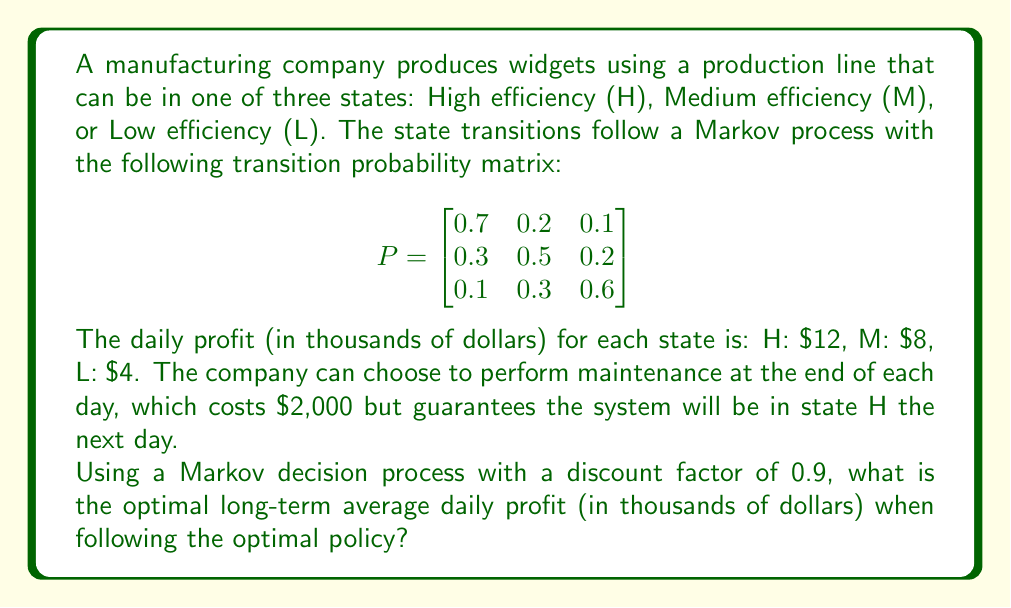Show me your answer to this math problem. To solve this Markov decision process, we'll use value iteration:

1) Define the value function $V(s)$ for each state s ∈ {H, M, L}.

2) Initialize $V_0(s) = 0$ for all states.

3) For each iteration k, update the value function:

   $V_{k+1}(s) = \max\{R(s) + \gamma \sum_{s'} P(s'|s)V_k(s'), R_m + \gamma V_k(H)\}$

   Where:
   - $R(s)$ is the immediate reward in state s
   - $\gamma = 0.9$ is the discount factor
   - $R_m = -2$ is the maintenance cost
   - The first term represents not performing maintenance
   - The second term represents performing maintenance

4) Iterate until convergence (difference between iterations < ε, e.g., 0.001)

5) The optimal policy is then to choose the action that maximizes the value function.

Let's perform the iterations:

Iteration 1:
$V_1(H) = \max\{12 + 0.9(0.7 \cdot 0 + 0.2 \cdot 0 + 0.1 \cdot 0), -2 + 0.9 \cdot 0\} = 12$
$V_1(M) = \max\{8 + 0.9(0.3 \cdot 0 + 0.5 \cdot 0 + 0.2 \cdot 0), -2 + 0.9 \cdot 0\} = 8$
$V_1(L) = \max\{4 + 0.9(0.1 \cdot 0 + 0.3 \cdot 0 + 0.6 \cdot 0), -2 + 0.9 \cdot 0\} = 4$

Iteration 2:
$V_2(H) = \max\{12 + 0.9(0.7 \cdot 12 + 0.2 \cdot 8 + 0.1 \cdot 4), -2 + 0.9 \cdot 12\} = 22.68$
$V_2(M) = \max\{8 + 0.9(0.3 \cdot 12 + 0.5 \cdot 8 + 0.2 \cdot 4), -2 + 0.9 \cdot 12\} = 16.44$
$V_2(L) = \max\{4 + 0.9(0.1 \cdot 12 + 0.3 \cdot 8 + 0.6 \cdot 4), -2 + 0.9 \cdot 12\} = 10.8$

Continuing this process until convergence, we get:

$V^*(H) ≈ 91.67$
$V^*(M) ≈ 87.50$
$V^*(L) ≈ 85.42$

The optimal policy is to not perform maintenance in any state.

To calculate the long-term average daily profit, we need to find the stationary distribution π of the Markov chain:

$\pi P = \pi$
$\pi_H + \pi_M + \pi_L = 1$

Solving this system of equations:
$\pi_H ≈ 0.4138$
$\pi_M ≈ 0.3448$
$\pi_L ≈ 0.2414$

The long-term average daily profit is:
$0.4138 \cdot 12 + 0.3448 \cdot 8 + 0.2414 \cdot 4 ≈ 8.69$
Answer: $8.69 thousand 